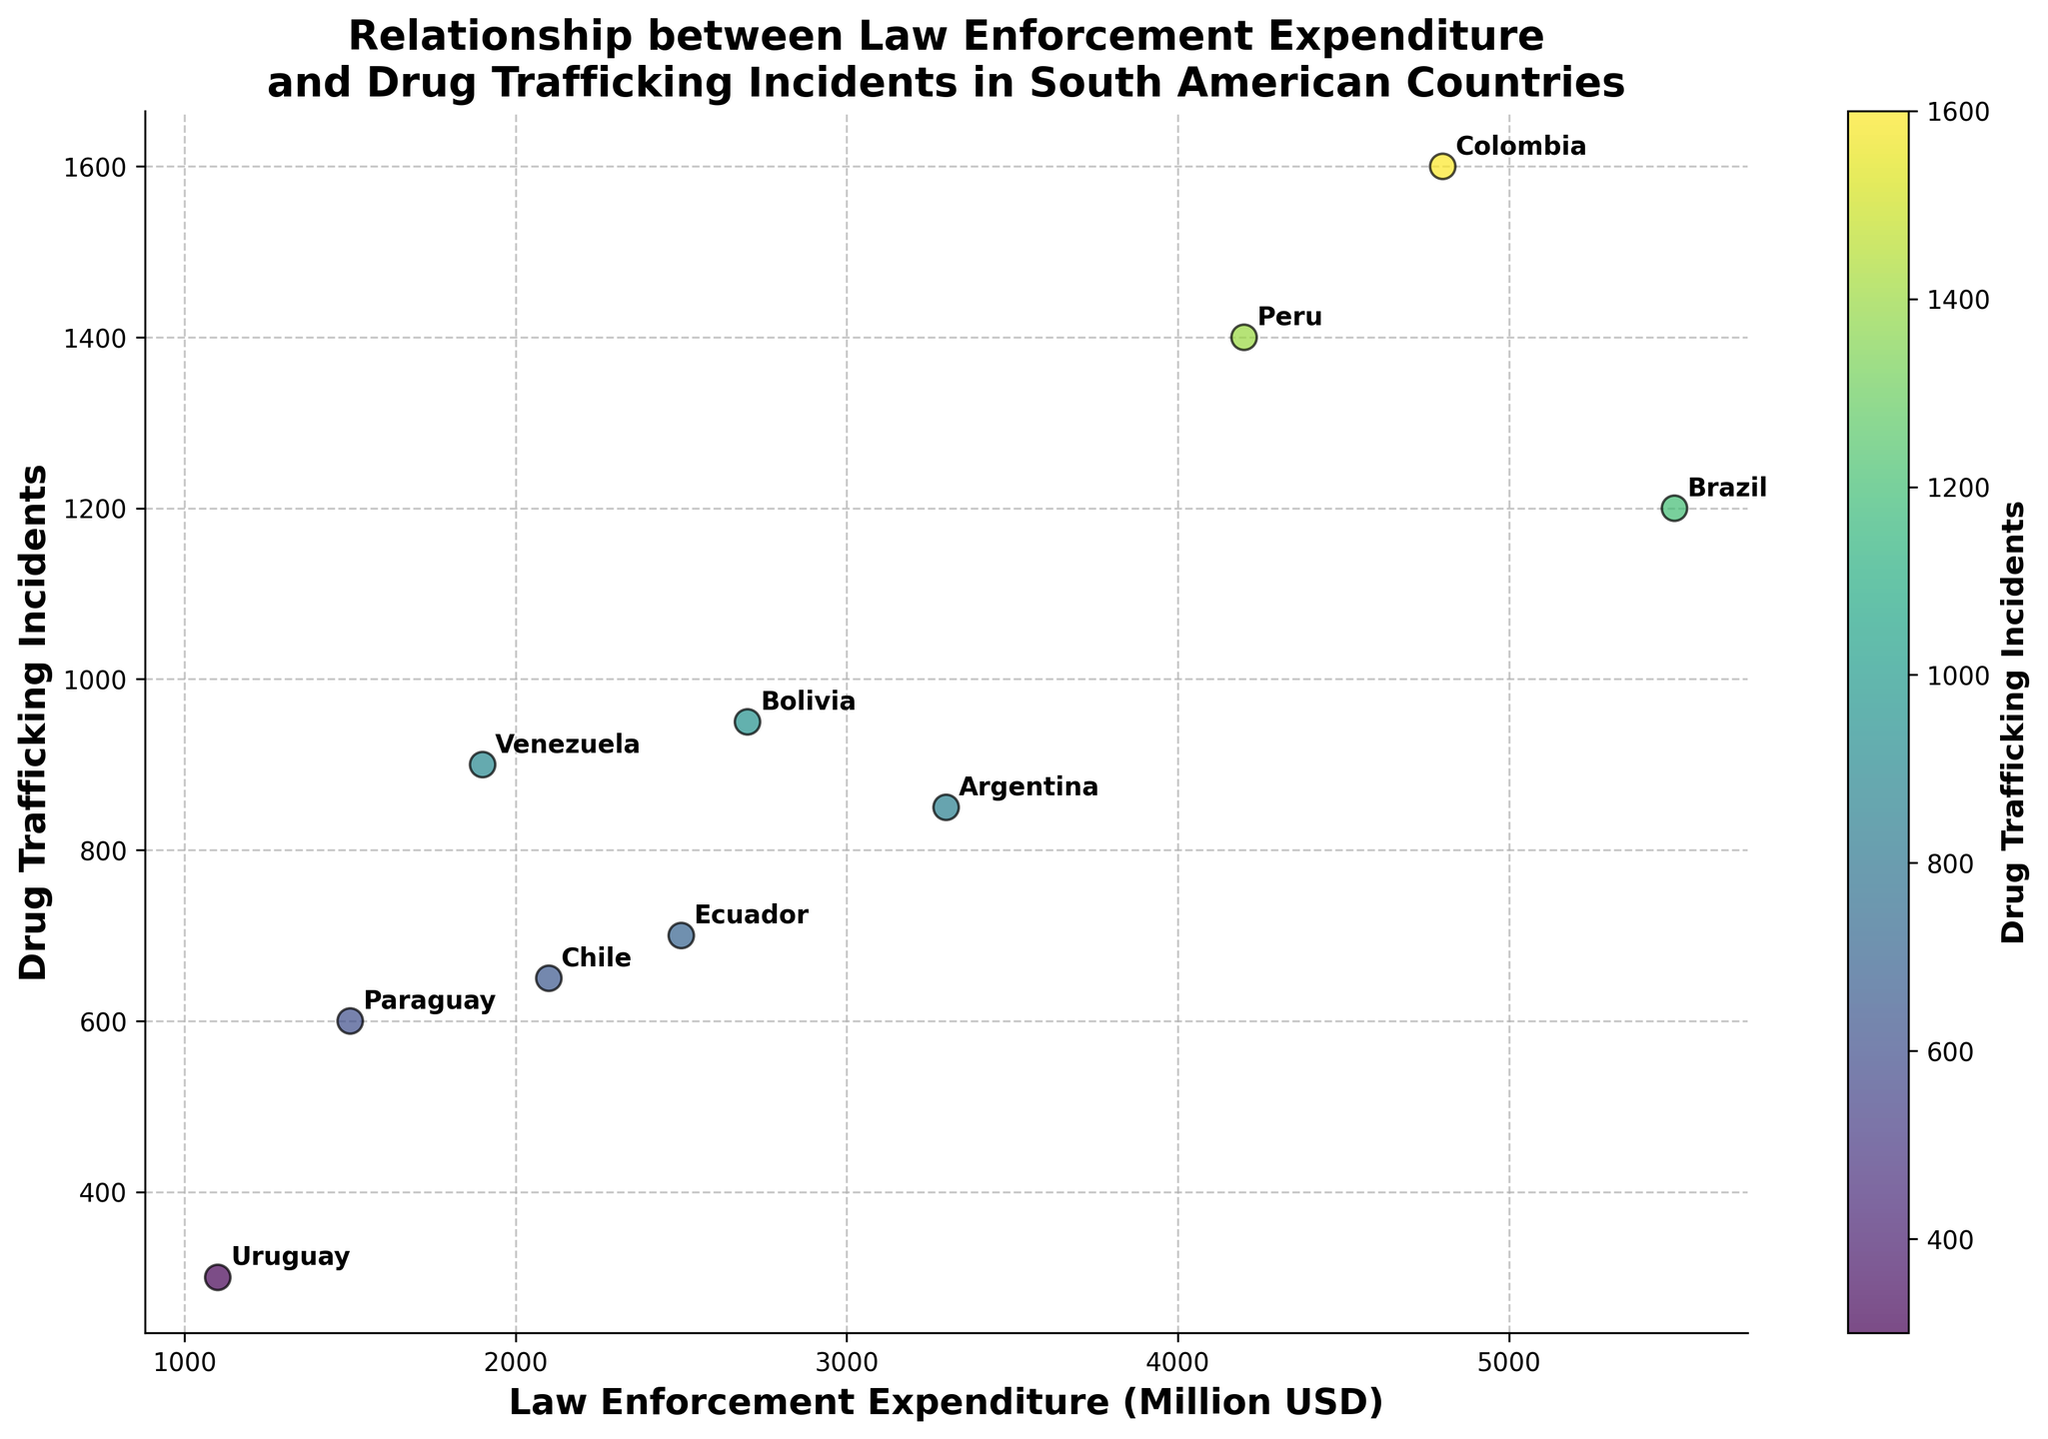What is the title of the figure? The title is displayed at the top of the figure in a larger font size. It gives a brief description of the content shown in the figure. The title reads "Relationship between Law Enforcement Expenditure and Drug Trafficking Incidents in South American Countries".
Answer: Relationship between Law Enforcement Expenditure and Drug Trafficking Incidents in South American Countries How many countries are displayed in the scatter plot? The number of data points (circles) on the scatter plot indicates the number of countries. Each data point represents one country, and there are 10 data points in the scatter plot.
Answer: 10 Which country has the highest number of drug trafficking incidents? By looking at the scatter plot, we can identify the country placed at the highest y-coordinate. Colombia is positioned at the highest point on the y-axis, indicating it has the maximum drug trafficking incidents.
Answer: Colombia What is the relationship between law enforcement expenditure and drug trafficking incidents in Chile and Uruguay? Chile and Uruguay are labeled on the scatter plot. Chile has higher law enforcement expenditure (~2100) and more drug trafficking incidents (~650) compared to Uruguay, which has lower law enforcement expenditure (~1100) and fewer drug trafficking incidents (~300).
Answer: Chile has higher values for both metrics compared to Uruguay Which country has the least law enforcement expenditure, and what is its corresponding number of drug trafficking incidents? By observing the x-axis for the smallest value, we find Uruguay at 1100 Million USD of expenditure. The corresponding y-value shows 300 drug trafficking incidents for Uruguay.
Answer: Uruguay, 300 What is the average law enforcement expenditure among all the countries shown? Add up all the expenditure values and divide by the number of countries: (5500 + 3300 + 4800 + 4200 + 2100 + 2500 + 1900 + 2700 + 1500 + 1100) / 10 = 32600 / 10 = 3260 Million USD.
Answer: 3260 Million USD Which country has nearly the same number of drug trafficking incidents as Brazil, and what is its law enforcement expenditure? Brazil has about 1200 incidents. Compare this with other y-values to find Peru (roughly 1400 incidents), and its expenditure is 4200 Million USD.
Answer: Peru, 4200 Million USD Is there a clear trend or pattern between law enforcement expenditure and drug trafficking incidents among these South American countries? The scatter plot shows points scattered around, indicating a possible positive correlation, where higher expenditure might be associated with more incidents, but there is no clear linear trend or pattern evident.
Answer: Possible positive correlation, but no clear trend How does the number of drug trafficking incidents in Venezuela compare to Ecuador? Locate both countries on the scatter plot. Venezuela has about 900 incidents, whereas Ecuador has about 700 incidents, so Venezuela has more incidents than Ecuador.
Answer: Venezuela has more incidents than Ecuador What can be inferred about the effectiveness of law enforcement expenditure when comparing Colombia and Bolivia? Colombia, with higher expenditure (4800 Million USD) and significantly high incidents (1600), does not show fewer incidents compared to Bolivia, which has lower expenditure (2700 Million USD) and fewer incidents (950). This might suggest that higher expenditure does not directly translate to fewer incidents in these cases.
Answer: Higher expenditure does not directly correlate with fewer incidents 